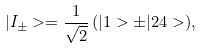<formula> <loc_0><loc_0><loc_500><loc_500>| I _ { \pm } > = \frac { 1 } { \sqrt { 2 } } \, ( | 1 > \pm | 2 4 > ) ,</formula> 